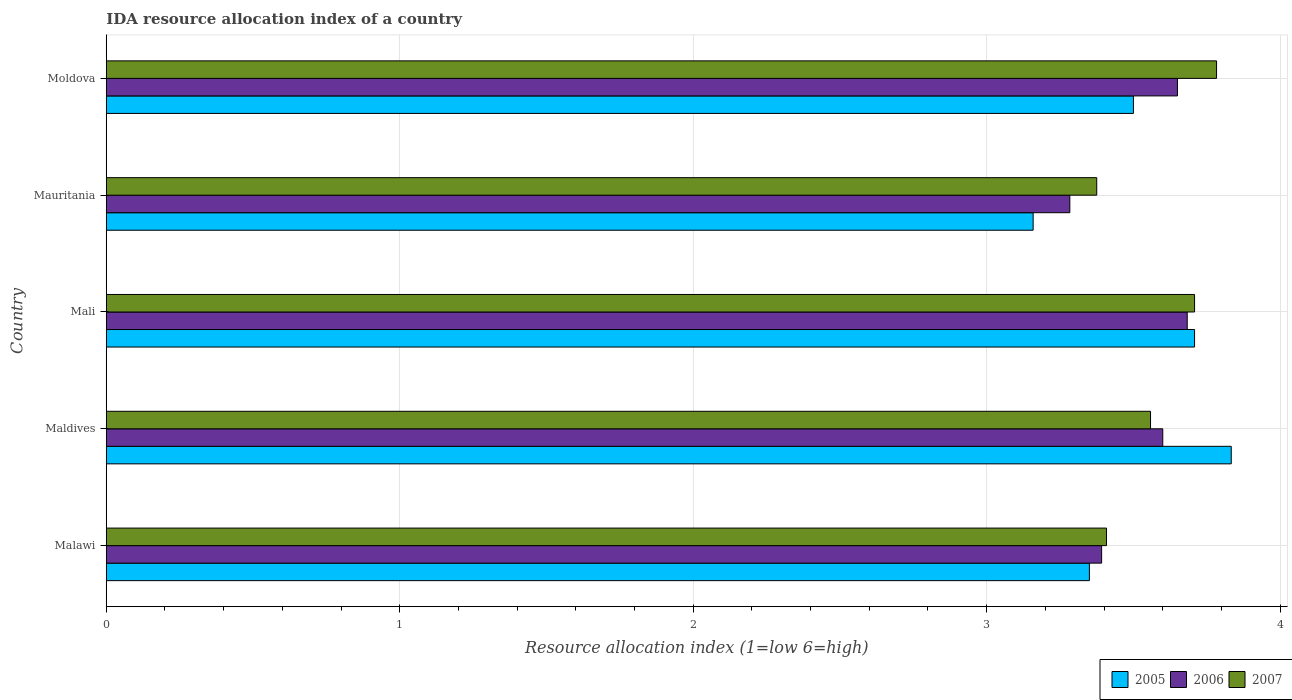How many different coloured bars are there?
Provide a succinct answer. 3. How many groups of bars are there?
Keep it short and to the point. 5. Are the number of bars per tick equal to the number of legend labels?
Make the answer very short. Yes. Are the number of bars on each tick of the Y-axis equal?
Offer a very short reply. Yes. How many bars are there on the 5th tick from the top?
Provide a short and direct response. 3. How many bars are there on the 2nd tick from the bottom?
Make the answer very short. 3. What is the label of the 1st group of bars from the top?
Offer a very short reply. Moldova. In how many cases, is the number of bars for a given country not equal to the number of legend labels?
Ensure brevity in your answer.  0. Across all countries, what is the maximum IDA resource allocation index in 2007?
Provide a short and direct response. 3.78. Across all countries, what is the minimum IDA resource allocation index in 2006?
Your answer should be compact. 3.28. In which country was the IDA resource allocation index in 2007 maximum?
Keep it short and to the point. Moldova. In which country was the IDA resource allocation index in 2006 minimum?
Provide a short and direct response. Mauritania. What is the total IDA resource allocation index in 2006 in the graph?
Ensure brevity in your answer.  17.61. What is the difference between the IDA resource allocation index in 2006 in Malawi and that in Mali?
Your response must be concise. -0.29. What is the difference between the IDA resource allocation index in 2007 in Malawi and the IDA resource allocation index in 2006 in Mauritania?
Your response must be concise. 0.12. What is the average IDA resource allocation index in 2007 per country?
Ensure brevity in your answer.  3.57. What is the difference between the IDA resource allocation index in 2006 and IDA resource allocation index in 2007 in Mali?
Provide a short and direct response. -0.02. In how many countries, is the IDA resource allocation index in 2007 greater than 2.2 ?
Offer a very short reply. 5. What is the ratio of the IDA resource allocation index in 2007 in Mauritania to that in Moldova?
Ensure brevity in your answer.  0.89. Is the IDA resource allocation index in 2005 in Malawi less than that in Mauritania?
Provide a succinct answer. No. Is the difference between the IDA resource allocation index in 2006 in Mauritania and Moldova greater than the difference between the IDA resource allocation index in 2007 in Mauritania and Moldova?
Provide a short and direct response. Yes. What is the difference between the highest and the second highest IDA resource allocation index in 2007?
Your response must be concise. 0.08. What is the difference between the highest and the lowest IDA resource allocation index in 2005?
Your answer should be very brief. 0.67. Is the sum of the IDA resource allocation index in 2006 in Mauritania and Moldova greater than the maximum IDA resource allocation index in 2007 across all countries?
Give a very brief answer. Yes. What does the 3rd bar from the top in Mali represents?
Ensure brevity in your answer.  2005. What does the 1st bar from the bottom in Mauritania represents?
Your answer should be very brief. 2005. Are all the bars in the graph horizontal?
Your answer should be very brief. Yes. How many countries are there in the graph?
Your answer should be very brief. 5. Does the graph contain any zero values?
Your answer should be very brief. No. How many legend labels are there?
Offer a very short reply. 3. How are the legend labels stacked?
Make the answer very short. Horizontal. What is the title of the graph?
Your answer should be very brief. IDA resource allocation index of a country. Does "1973" appear as one of the legend labels in the graph?
Ensure brevity in your answer.  No. What is the label or title of the X-axis?
Ensure brevity in your answer.  Resource allocation index (1=low 6=high). What is the Resource allocation index (1=low 6=high) of 2005 in Malawi?
Your answer should be compact. 3.35. What is the Resource allocation index (1=low 6=high) of 2006 in Malawi?
Keep it short and to the point. 3.39. What is the Resource allocation index (1=low 6=high) of 2007 in Malawi?
Offer a terse response. 3.41. What is the Resource allocation index (1=low 6=high) in 2005 in Maldives?
Give a very brief answer. 3.83. What is the Resource allocation index (1=low 6=high) of 2006 in Maldives?
Keep it short and to the point. 3.6. What is the Resource allocation index (1=low 6=high) in 2007 in Maldives?
Offer a terse response. 3.56. What is the Resource allocation index (1=low 6=high) in 2005 in Mali?
Your answer should be compact. 3.71. What is the Resource allocation index (1=low 6=high) in 2006 in Mali?
Provide a short and direct response. 3.68. What is the Resource allocation index (1=low 6=high) of 2007 in Mali?
Give a very brief answer. 3.71. What is the Resource allocation index (1=low 6=high) in 2005 in Mauritania?
Your response must be concise. 3.16. What is the Resource allocation index (1=low 6=high) of 2006 in Mauritania?
Your response must be concise. 3.28. What is the Resource allocation index (1=low 6=high) in 2007 in Mauritania?
Your answer should be very brief. 3.38. What is the Resource allocation index (1=low 6=high) of 2005 in Moldova?
Your response must be concise. 3.5. What is the Resource allocation index (1=low 6=high) of 2006 in Moldova?
Your answer should be very brief. 3.65. What is the Resource allocation index (1=low 6=high) of 2007 in Moldova?
Make the answer very short. 3.78. Across all countries, what is the maximum Resource allocation index (1=low 6=high) in 2005?
Make the answer very short. 3.83. Across all countries, what is the maximum Resource allocation index (1=low 6=high) in 2006?
Provide a succinct answer. 3.68. Across all countries, what is the maximum Resource allocation index (1=low 6=high) of 2007?
Provide a succinct answer. 3.78. Across all countries, what is the minimum Resource allocation index (1=low 6=high) of 2005?
Your response must be concise. 3.16. Across all countries, what is the minimum Resource allocation index (1=low 6=high) in 2006?
Your response must be concise. 3.28. Across all countries, what is the minimum Resource allocation index (1=low 6=high) in 2007?
Your answer should be very brief. 3.38. What is the total Resource allocation index (1=low 6=high) of 2005 in the graph?
Make the answer very short. 17.55. What is the total Resource allocation index (1=low 6=high) of 2006 in the graph?
Give a very brief answer. 17.61. What is the total Resource allocation index (1=low 6=high) in 2007 in the graph?
Make the answer very short. 17.83. What is the difference between the Resource allocation index (1=low 6=high) in 2005 in Malawi and that in Maldives?
Your answer should be very brief. -0.48. What is the difference between the Resource allocation index (1=low 6=high) in 2006 in Malawi and that in Maldives?
Give a very brief answer. -0.21. What is the difference between the Resource allocation index (1=low 6=high) of 2005 in Malawi and that in Mali?
Ensure brevity in your answer.  -0.36. What is the difference between the Resource allocation index (1=low 6=high) of 2006 in Malawi and that in Mali?
Offer a terse response. -0.29. What is the difference between the Resource allocation index (1=low 6=high) in 2005 in Malawi and that in Mauritania?
Keep it short and to the point. 0.19. What is the difference between the Resource allocation index (1=low 6=high) of 2006 in Malawi and that in Mauritania?
Offer a very short reply. 0.11. What is the difference between the Resource allocation index (1=low 6=high) of 2005 in Malawi and that in Moldova?
Your response must be concise. -0.15. What is the difference between the Resource allocation index (1=low 6=high) of 2006 in Malawi and that in Moldova?
Offer a very short reply. -0.26. What is the difference between the Resource allocation index (1=low 6=high) in 2007 in Malawi and that in Moldova?
Your response must be concise. -0.38. What is the difference between the Resource allocation index (1=low 6=high) of 2006 in Maldives and that in Mali?
Offer a very short reply. -0.08. What is the difference between the Resource allocation index (1=low 6=high) in 2005 in Maldives and that in Mauritania?
Offer a very short reply. 0.68. What is the difference between the Resource allocation index (1=low 6=high) in 2006 in Maldives and that in Mauritania?
Make the answer very short. 0.32. What is the difference between the Resource allocation index (1=low 6=high) of 2007 in Maldives and that in Mauritania?
Your answer should be very brief. 0.18. What is the difference between the Resource allocation index (1=low 6=high) of 2005 in Maldives and that in Moldova?
Keep it short and to the point. 0.33. What is the difference between the Resource allocation index (1=low 6=high) in 2007 in Maldives and that in Moldova?
Offer a terse response. -0.23. What is the difference between the Resource allocation index (1=low 6=high) of 2005 in Mali and that in Mauritania?
Make the answer very short. 0.55. What is the difference between the Resource allocation index (1=low 6=high) in 2006 in Mali and that in Mauritania?
Offer a terse response. 0.4. What is the difference between the Resource allocation index (1=low 6=high) in 2005 in Mali and that in Moldova?
Give a very brief answer. 0.21. What is the difference between the Resource allocation index (1=low 6=high) in 2007 in Mali and that in Moldova?
Provide a short and direct response. -0.07. What is the difference between the Resource allocation index (1=low 6=high) in 2005 in Mauritania and that in Moldova?
Offer a terse response. -0.34. What is the difference between the Resource allocation index (1=low 6=high) in 2006 in Mauritania and that in Moldova?
Offer a very short reply. -0.37. What is the difference between the Resource allocation index (1=low 6=high) of 2007 in Mauritania and that in Moldova?
Ensure brevity in your answer.  -0.41. What is the difference between the Resource allocation index (1=low 6=high) in 2005 in Malawi and the Resource allocation index (1=low 6=high) in 2006 in Maldives?
Offer a terse response. -0.25. What is the difference between the Resource allocation index (1=low 6=high) in 2005 in Malawi and the Resource allocation index (1=low 6=high) in 2007 in Maldives?
Give a very brief answer. -0.21. What is the difference between the Resource allocation index (1=low 6=high) of 2006 in Malawi and the Resource allocation index (1=low 6=high) of 2007 in Maldives?
Provide a short and direct response. -0.17. What is the difference between the Resource allocation index (1=low 6=high) of 2005 in Malawi and the Resource allocation index (1=low 6=high) of 2007 in Mali?
Your answer should be very brief. -0.36. What is the difference between the Resource allocation index (1=low 6=high) of 2006 in Malawi and the Resource allocation index (1=low 6=high) of 2007 in Mali?
Your answer should be compact. -0.32. What is the difference between the Resource allocation index (1=low 6=high) of 2005 in Malawi and the Resource allocation index (1=low 6=high) of 2006 in Mauritania?
Provide a short and direct response. 0.07. What is the difference between the Resource allocation index (1=low 6=high) in 2005 in Malawi and the Resource allocation index (1=low 6=high) in 2007 in Mauritania?
Ensure brevity in your answer.  -0.03. What is the difference between the Resource allocation index (1=low 6=high) of 2006 in Malawi and the Resource allocation index (1=low 6=high) of 2007 in Mauritania?
Your answer should be very brief. 0.02. What is the difference between the Resource allocation index (1=low 6=high) of 2005 in Malawi and the Resource allocation index (1=low 6=high) of 2006 in Moldova?
Your answer should be compact. -0.3. What is the difference between the Resource allocation index (1=low 6=high) in 2005 in Malawi and the Resource allocation index (1=low 6=high) in 2007 in Moldova?
Offer a very short reply. -0.43. What is the difference between the Resource allocation index (1=low 6=high) in 2006 in Malawi and the Resource allocation index (1=low 6=high) in 2007 in Moldova?
Give a very brief answer. -0.39. What is the difference between the Resource allocation index (1=low 6=high) of 2005 in Maldives and the Resource allocation index (1=low 6=high) of 2007 in Mali?
Offer a terse response. 0.12. What is the difference between the Resource allocation index (1=low 6=high) of 2006 in Maldives and the Resource allocation index (1=low 6=high) of 2007 in Mali?
Offer a terse response. -0.11. What is the difference between the Resource allocation index (1=low 6=high) in 2005 in Maldives and the Resource allocation index (1=low 6=high) in 2006 in Mauritania?
Your response must be concise. 0.55. What is the difference between the Resource allocation index (1=low 6=high) in 2005 in Maldives and the Resource allocation index (1=low 6=high) in 2007 in Mauritania?
Give a very brief answer. 0.46. What is the difference between the Resource allocation index (1=low 6=high) of 2006 in Maldives and the Resource allocation index (1=low 6=high) of 2007 in Mauritania?
Ensure brevity in your answer.  0.23. What is the difference between the Resource allocation index (1=low 6=high) of 2005 in Maldives and the Resource allocation index (1=low 6=high) of 2006 in Moldova?
Give a very brief answer. 0.18. What is the difference between the Resource allocation index (1=low 6=high) of 2006 in Maldives and the Resource allocation index (1=low 6=high) of 2007 in Moldova?
Keep it short and to the point. -0.18. What is the difference between the Resource allocation index (1=low 6=high) in 2005 in Mali and the Resource allocation index (1=low 6=high) in 2006 in Mauritania?
Your response must be concise. 0.42. What is the difference between the Resource allocation index (1=low 6=high) in 2006 in Mali and the Resource allocation index (1=low 6=high) in 2007 in Mauritania?
Your response must be concise. 0.31. What is the difference between the Resource allocation index (1=low 6=high) in 2005 in Mali and the Resource allocation index (1=low 6=high) in 2006 in Moldova?
Provide a short and direct response. 0.06. What is the difference between the Resource allocation index (1=low 6=high) of 2005 in Mali and the Resource allocation index (1=low 6=high) of 2007 in Moldova?
Make the answer very short. -0.07. What is the difference between the Resource allocation index (1=low 6=high) in 2006 in Mali and the Resource allocation index (1=low 6=high) in 2007 in Moldova?
Make the answer very short. -0.1. What is the difference between the Resource allocation index (1=low 6=high) in 2005 in Mauritania and the Resource allocation index (1=low 6=high) in 2006 in Moldova?
Ensure brevity in your answer.  -0.49. What is the difference between the Resource allocation index (1=low 6=high) in 2005 in Mauritania and the Resource allocation index (1=low 6=high) in 2007 in Moldova?
Make the answer very short. -0.62. What is the average Resource allocation index (1=low 6=high) in 2005 per country?
Offer a terse response. 3.51. What is the average Resource allocation index (1=low 6=high) in 2006 per country?
Provide a succinct answer. 3.52. What is the average Resource allocation index (1=low 6=high) in 2007 per country?
Make the answer very short. 3.57. What is the difference between the Resource allocation index (1=low 6=high) in 2005 and Resource allocation index (1=low 6=high) in 2006 in Malawi?
Your answer should be compact. -0.04. What is the difference between the Resource allocation index (1=low 6=high) in 2005 and Resource allocation index (1=low 6=high) in 2007 in Malawi?
Your answer should be very brief. -0.06. What is the difference between the Resource allocation index (1=low 6=high) in 2006 and Resource allocation index (1=low 6=high) in 2007 in Malawi?
Offer a terse response. -0.02. What is the difference between the Resource allocation index (1=low 6=high) in 2005 and Resource allocation index (1=low 6=high) in 2006 in Maldives?
Give a very brief answer. 0.23. What is the difference between the Resource allocation index (1=low 6=high) of 2005 and Resource allocation index (1=low 6=high) of 2007 in Maldives?
Your response must be concise. 0.28. What is the difference between the Resource allocation index (1=low 6=high) of 2006 and Resource allocation index (1=low 6=high) of 2007 in Maldives?
Make the answer very short. 0.04. What is the difference between the Resource allocation index (1=low 6=high) in 2005 and Resource allocation index (1=low 6=high) in 2006 in Mali?
Your answer should be compact. 0.03. What is the difference between the Resource allocation index (1=low 6=high) in 2006 and Resource allocation index (1=low 6=high) in 2007 in Mali?
Your answer should be very brief. -0.03. What is the difference between the Resource allocation index (1=low 6=high) in 2005 and Resource allocation index (1=low 6=high) in 2006 in Mauritania?
Provide a short and direct response. -0.12. What is the difference between the Resource allocation index (1=low 6=high) of 2005 and Resource allocation index (1=low 6=high) of 2007 in Mauritania?
Your answer should be compact. -0.22. What is the difference between the Resource allocation index (1=low 6=high) in 2006 and Resource allocation index (1=low 6=high) in 2007 in Mauritania?
Provide a succinct answer. -0.09. What is the difference between the Resource allocation index (1=low 6=high) in 2005 and Resource allocation index (1=low 6=high) in 2007 in Moldova?
Your answer should be compact. -0.28. What is the difference between the Resource allocation index (1=low 6=high) of 2006 and Resource allocation index (1=low 6=high) of 2007 in Moldova?
Offer a terse response. -0.13. What is the ratio of the Resource allocation index (1=low 6=high) of 2005 in Malawi to that in Maldives?
Keep it short and to the point. 0.87. What is the ratio of the Resource allocation index (1=low 6=high) in 2006 in Malawi to that in Maldives?
Your answer should be compact. 0.94. What is the ratio of the Resource allocation index (1=low 6=high) in 2007 in Malawi to that in Maldives?
Give a very brief answer. 0.96. What is the ratio of the Resource allocation index (1=low 6=high) of 2005 in Malawi to that in Mali?
Your response must be concise. 0.9. What is the ratio of the Resource allocation index (1=low 6=high) of 2006 in Malawi to that in Mali?
Your response must be concise. 0.92. What is the ratio of the Resource allocation index (1=low 6=high) in 2007 in Malawi to that in Mali?
Offer a very short reply. 0.92. What is the ratio of the Resource allocation index (1=low 6=high) of 2005 in Malawi to that in Mauritania?
Keep it short and to the point. 1.06. What is the ratio of the Resource allocation index (1=low 6=high) in 2006 in Malawi to that in Mauritania?
Ensure brevity in your answer.  1.03. What is the ratio of the Resource allocation index (1=low 6=high) of 2007 in Malawi to that in Mauritania?
Provide a succinct answer. 1.01. What is the ratio of the Resource allocation index (1=low 6=high) in 2005 in Malawi to that in Moldova?
Provide a short and direct response. 0.96. What is the ratio of the Resource allocation index (1=low 6=high) of 2006 in Malawi to that in Moldova?
Your answer should be very brief. 0.93. What is the ratio of the Resource allocation index (1=low 6=high) in 2007 in Malawi to that in Moldova?
Provide a succinct answer. 0.9. What is the ratio of the Resource allocation index (1=low 6=high) in 2005 in Maldives to that in Mali?
Offer a very short reply. 1.03. What is the ratio of the Resource allocation index (1=low 6=high) of 2006 in Maldives to that in Mali?
Offer a terse response. 0.98. What is the ratio of the Resource allocation index (1=low 6=high) of 2007 in Maldives to that in Mali?
Keep it short and to the point. 0.96. What is the ratio of the Resource allocation index (1=low 6=high) of 2005 in Maldives to that in Mauritania?
Provide a succinct answer. 1.21. What is the ratio of the Resource allocation index (1=low 6=high) in 2006 in Maldives to that in Mauritania?
Your answer should be very brief. 1.1. What is the ratio of the Resource allocation index (1=low 6=high) of 2007 in Maldives to that in Mauritania?
Offer a terse response. 1.05. What is the ratio of the Resource allocation index (1=low 6=high) of 2005 in Maldives to that in Moldova?
Your response must be concise. 1.1. What is the ratio of the Resource allocation index (1=low 6=high) in 2006 in Maldives to that in Moldova?
Provide a succinct answer. 0.99. What is the ratio of the Resource allocation index (1=low 6=high) of 2007 in Maldives to that in Moldova?
Provide a succinct answer. 0.94. What is the ratio of the Resource allocation index (1=low 6=high) of 2005 in Mali to that in Mauritania?
Provide a short and direct response. 1.17. What is the ratio of the Resource allocation index (1=low 6=high) of 2006 in Mali to that in Mauritania?
Offer a very short reply. 1.12. What is the ratio of the Resource allocation index (1=low 6=high) of 2007 in Mali to that in Mauritania?
Give a very brief answer. 1.1. What is the ratio of the Resource allocation index (1=low 6=high) in 2005 in Mali to that in Moldova?
Offer a very short reply. 1.06. What is the ratio of the Resource allocation index (1=low 6=high) in 2006 in Mali to that in Moldova?
Your answer should be compact. 1.01. What is the ratio of the Resource allocation index (1=low 6=high) of 2007 in Mali to that in Moldova?
Offer a very short reply. 0.98. What is the ratio of the Resource allocation index (1=low 6=high) in 2005 in Mauritania to that in Moldova?
Make the answer very short. 0.9. What is the ratio of the Resource allocation index (1=low 6=high) of 2006 in Mauritania to that in Moldova?
Provide a succinct answer. 0.9. What is the ratio of the Resource allocation index (1=low 6=high) of 2007 in Mauritania to that in Moldova?
Give a very brief answer. 0.89. What is the difference between the highest and the second highest Resource allocation index (1=low 6=high) in 2006?
Offer a very short reply. 0.03. What is the difference between the highest and the second highest Resource allocation index (1=low 6=high) of 2007?
Provide a short and direct response. 0.07. What is the difference between the highest and the lowest Resource allocation index (1=low 6=high) in 2005?
Give a very brief answer. 0.68. What is the difference between the highest and the lowest Resource allocation index (1=low 6=high) of 2007?
Your answer should be compact. 0.41. 